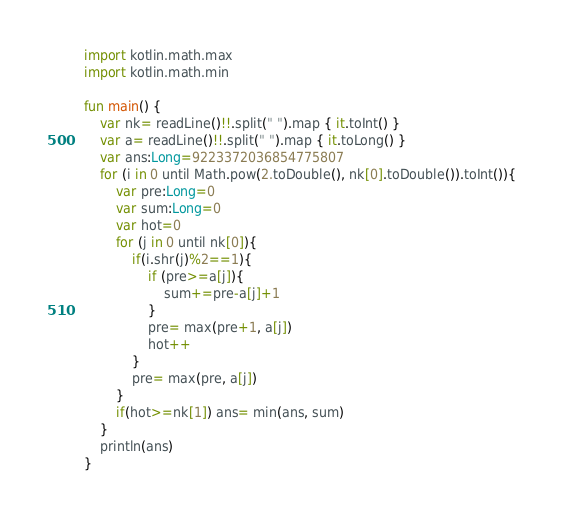Convert code to text. <code><loc_0><loc_0><loc_500><loc_500><_Kotlin_>import kotlin.math.max
import kotlin.math.min

fun main() {
    var nk= readLine()!!.split(" ").map { it.toInt() }
    var a= readLine()!!.split(" ").map { it.toLong() }
    var ans:Long=9223372036854775807
    for (i in 0 until Math.pow(2.toDouble(), nk[0].toDouble()).toInt()){
        var pre:Long=0
        var sum:Long=0
        var hot=0
        for (j in 0 until nk[0]){
            if(i.shr(j)%2==1){
                if (pre>=a[j]){
                    sum+=pre-a[j]+1
                }
                pre= max(pre+1, a[j])
                hot++
            }
            pre= max(pre, a[j])
        }
        if(hot>=nk[1]) ans= min(ans, sum)
    }
    println(ans)
}</code> 